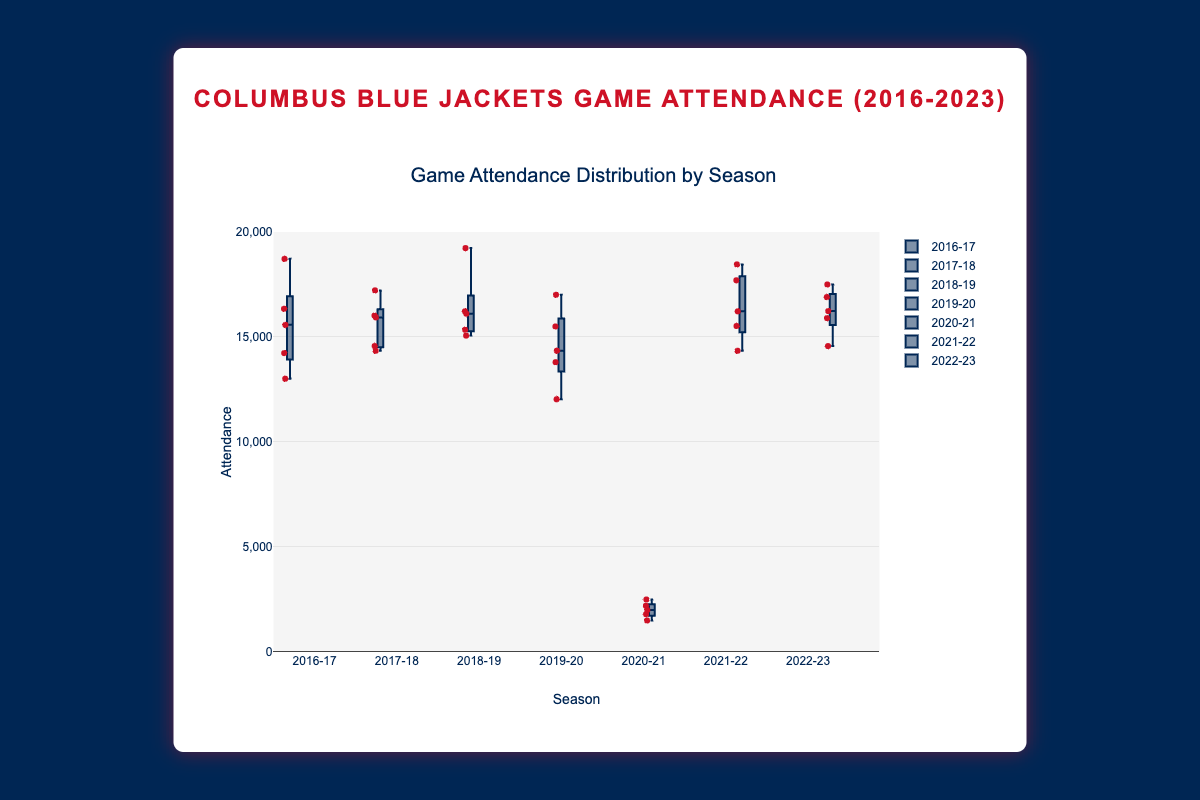What's the title of the figure? The title of the figure is displayed at the top and clearly states what the data represents. In this case, the title is "Game Attendance Distribution by Season".
Answer: Game Attendance Distribution by Season Which season has the widest range of attendance? To determine the widest range, we look at the vertical spread of the box plots. The wider the spread from the lowest point to the highest point, the wider the range. The 2020-21 season has a noticeable wide range due to pandemic restrictions resulting in significantly lower attendance numbers.
Answer: 2020-21 What's the range of attendance for the season 2020-21? To find the range, we identify the minimum and maximum values of the attendance data for the 2020-21 season. The minimum is 1500 and the maximum is 2500, making the range (2500-1500).
Answer: 1000 Which season has the median attendance closest to 16000? The median is the line inside the box of each box plot. We can see that the 2016-17, 2017-18, 2018-19, and 2019-20 seasons all have medians close to 16000, but the 2018-19 season's median is slightly above the others and seems closest to 16000.
Answer: 2018-19 How did the COVID-19 pandemic affect attendance in the 2020-21 season? Considering the 2020-21 season, attendance values are significantly lower across all games compared to other seasons. The box plot shows that the maximum attendance is 2500, which is much lower than other seasons, indicating a major drop due to the pandemic.
Answer: Significant drop Which seasons have an attendance with interquartile range (IQR) less than 2000? The IQR is measured by the height of the box. 2017-18 and 2021-22 seasons have relatively smaller boxes compared to other seasons, indicating they have a lesser spread in attendance numbers.
Answer: 2017-18 and 2021-22 What's the highest attendance recorded and in which season? The highest attendance is represented by the top whisker or outlier point. The 2016-17 and 2018-19 seasons have attendances reaching approximately 19234. However, the exact highest value of 19234 occurs in the 2018-19 season.
Answer: 19234 in 2018-19 How does the 2022-23 season's attendance distribution compare with the 2019-20 season? To compare, we observe the box plots for both seasons. The 2022-23 season has a higher median attendance and a tighter distribution (smaller IQR) compared to the 2019-20 season, indicating more consistent attendance across games in 2022-23.
Answer: 2022-23 has higher and more consistent attendance What visual features distinguish each season's attendance distribution? Each box plot shows the median, interquartile range (IQR), and whiskers. Notable differences include the extremely low range in 2020-21 due to pandemic restrictions, higher medians in 2018-19 and 2016-17, and generally consistent attendance noted in the 2021-22 and 2022-23 seasons.
Answer: Median, IQR, whiskers, outliers 